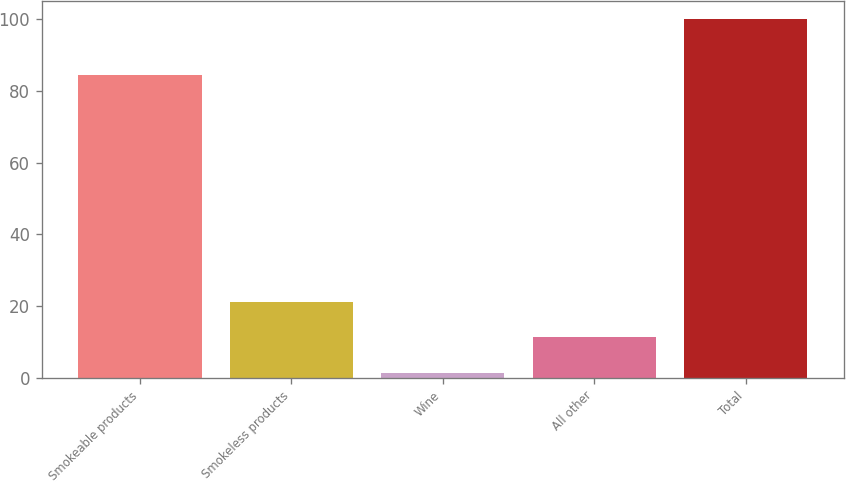Convert chart to OTSL. <chart><loc_0><loc_0><loc_500><loc_500><bar_chart><fcel>Smokeable products<fcel>Smokeless products<fcel>Wine<fcel>All other<fcel>Total<nl><fcel>84.5<fcel>21.12<fcel>1.4<fcel>11.26<fcel>100<nl></chart> 